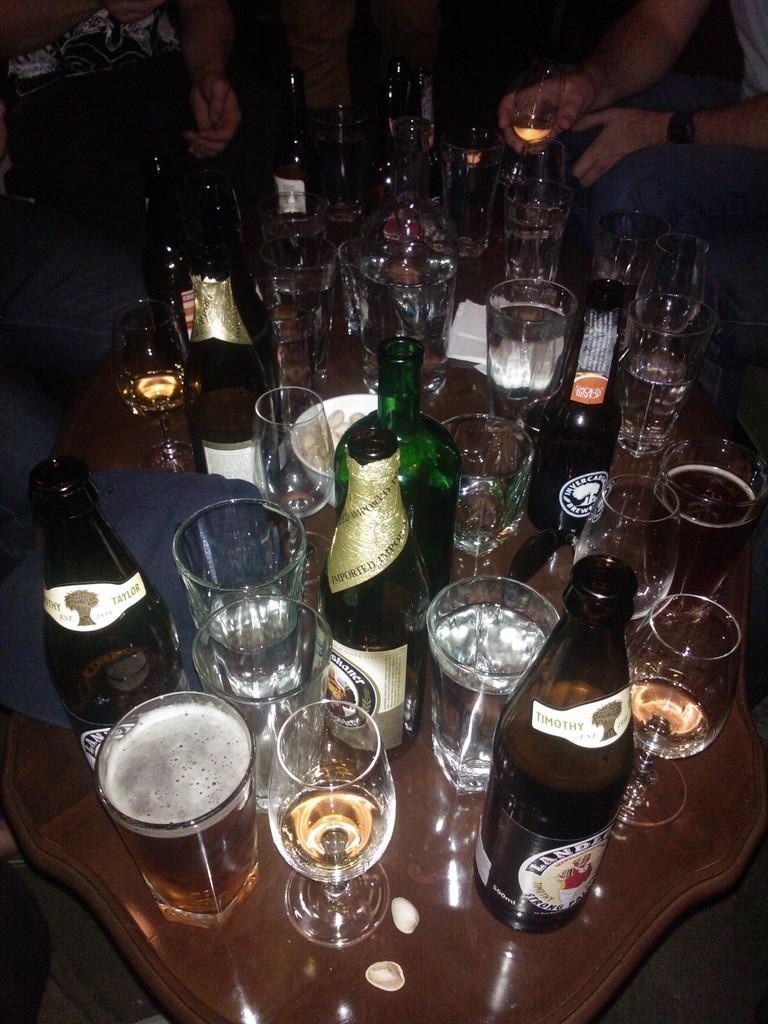Please provide a concise description of this image. In the middle of the image there is a table on the table there are some bottles and glasses and bowls. Top of the image few people are sitting and holding the glasses. 